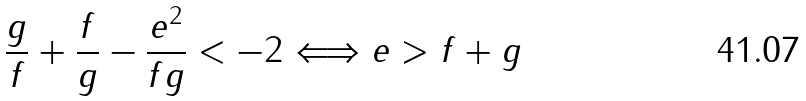Convert formula to latex. <formula><loc_0><loc_0><loc_500><loc_500>\frac { g } { f } + \frac { f } { g } - \frac { e ^ { 2 } } { f g } < - 2 \Longleftrightarrow e > f + g</formula> 